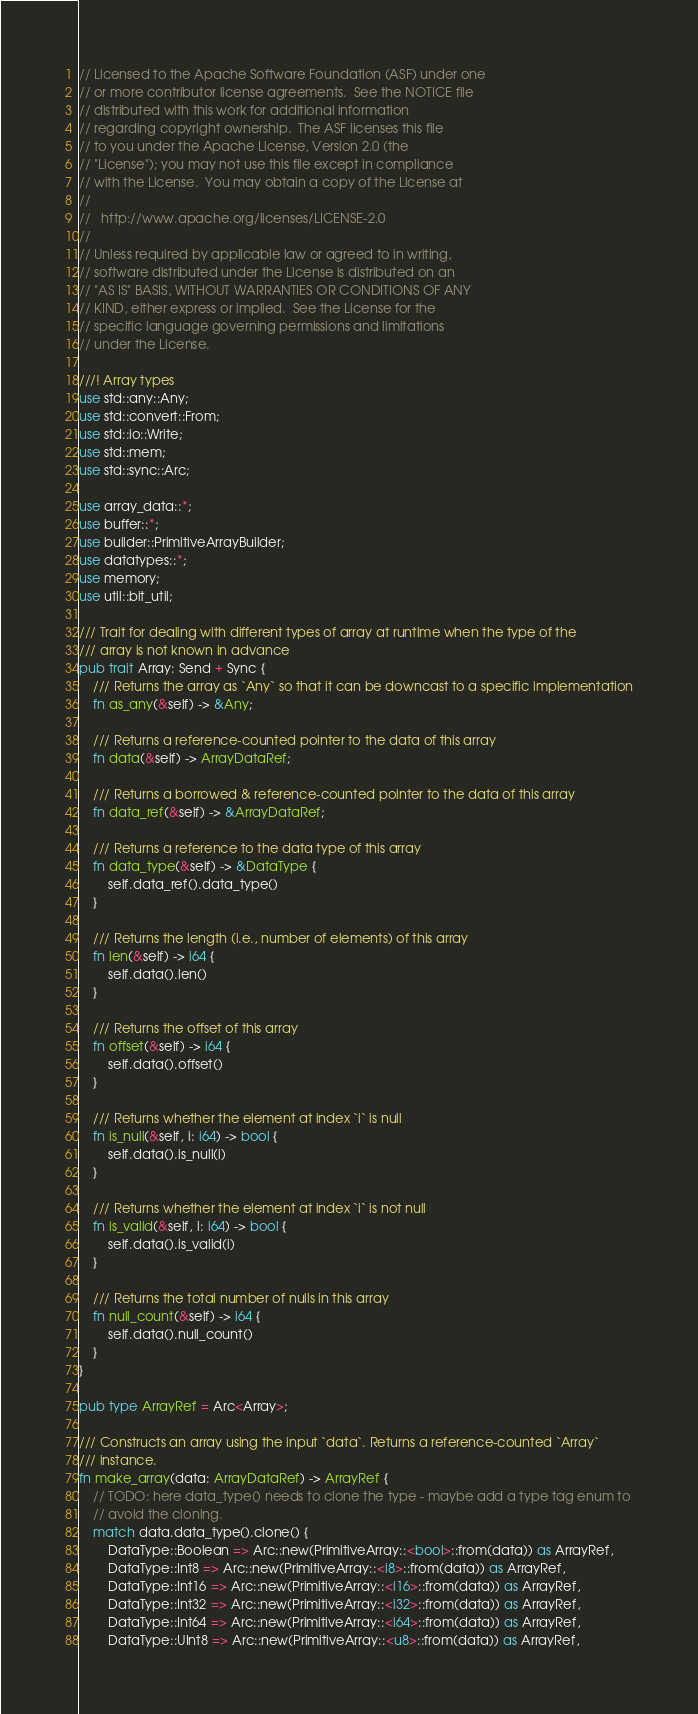Convert code to text. <code><loc_0><loc_0><loc_500><loc_500><_Rust_>// Licensed to the Apache Software Foundation (ASF) under one
// or more contributor license agreements.  See the NOTICE file
// distributed with this work for additional information
// regarding copyright ownership.  The ASF licenses this file
// to you under the Apache License, Version 2.0 (the
// "License"); you may not use this file except in compliance
// with the License.  You may obtain a copy of the License at
//
//   http://www.apache.org/licenses/LICENSE-2.0
//
// Unless required by applicable law or agreed to in writing,
// software distributed under the License is distributed on an
// "AS IS" BASIS, WITHOUT WARRANTIES OR CONDITIONS OF ANY
// KIND, either express or implied.  See the License for the
// specific language governing permissions and limitations
// under the License.

///! Array types
use std::any::Any;
use std::convert::From;
use std::io::Write;
use std::mem;
use std::sync::Arc;

use array_data::*;
use buffer::*;
use builder::PrimitiveArrayBuilder;
use datatypes::*;
use memory;
use util::bit_util;

/// Trait for dealing with different types of array at runtime when the type of the
/// array is not known in advance
pub trait Array: Send + Sync {
    /// Returns the array as `Any` so that it can be downcast to a specific implementation
    fn as_any(&self) -> &Any;

    /// Returns a reference-counted pointer to the data of this array
    fn data(&self) -> ArrayDataRef;

    /// Returns a borrowed & reference-counted pointer to the data of this array
    fn data_ref(&self) -> &ArrayDataRef;

    /// Returns a reference to the data type of this array
    fn data_type(&self) -> &DataType {
        self.data_ref().data_type()
    }

    /// Returns the length (i.e., number of elements) of this array
    fn len(&self) -> i64 {
        self.data().len()
    }

    /// Returns the offset of this array
    fn offset(&self) -> i64 {
        self.data().offset()
    }

    /// Returns whether the element at index `i` is null
    fn is_null(&self, i: i64) -> bool {
        self.data().is_null(i)
    }

    /// Returns whether the element at index `i` is not null
    fn is_valid(&self, i: i64) -> bool {
        self.data().is_valid(i)
    }

    /// Returns the total number of nulls in this array
    fn null_count(&self) -> i64 {
        self.data().null_count()
    }
}

pub type ArrayRef = Arc<Array>;

/// Constructs an array using the input `data`. Returns a reference-counted `Array`
/// instance.
fn make_array(data: ArrayDataRef) -> ArrayRef {
    // TODO: here data_type() needs to clone the type - maybe add a type tag enum to
    // avoid the cloning.
    match data.data_type().clone() {
        DataType::Boolean => Arc::new(PrimitiveArray::<bool>::from(data)) as ArrayRef,
        DataType::Int8 => Arc::new(PrimitiveArray::<i8>::from(data)) as ArrayRef,
        DataType::Int16 => Arc::new(PrimitiveArray::<i16>::from(data)) as ArrayRef,
        DataType::Int32 => Arc::new(PrimitiveArray::<i32>::from(data)) as ArrayRef,
        DataType::Int64 => Arc::new(PrimitiveArray::<i64>::from(data)) as ArrayRef,
        DataType::UInt8 => Arc::new(PrimitiveArray::<u8>::from(data)) as ArrayRef,</code> 